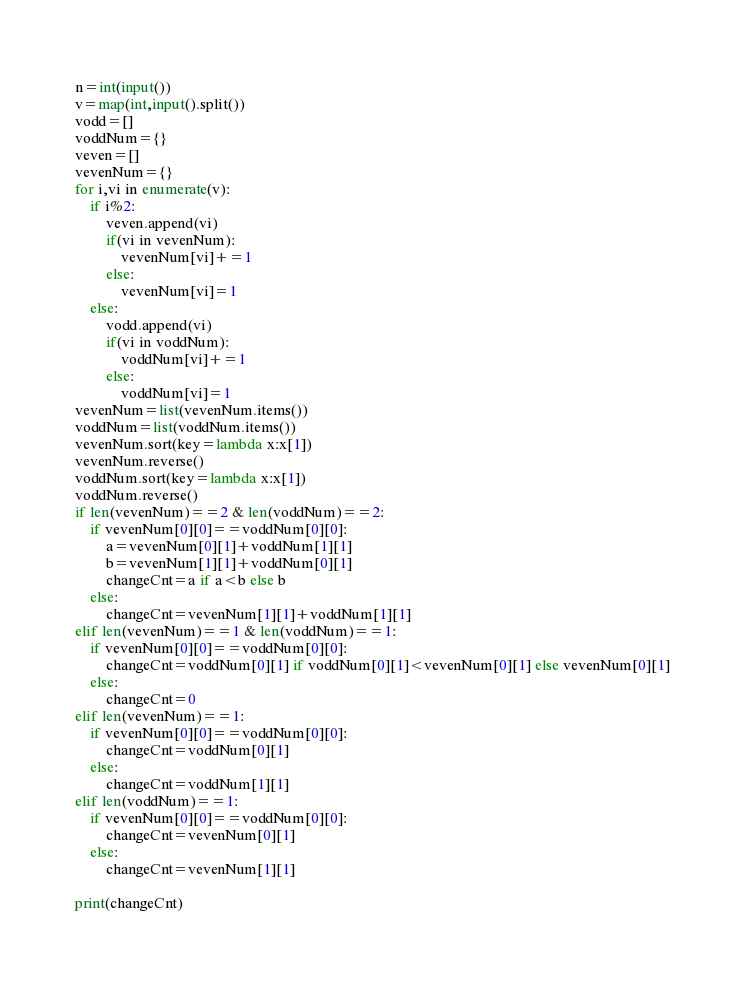Convert code to text. <code><loc_0><loc_0><loc_500><loc_500><_Python_>n=int(input())
v=map(int,input().split())
vodd=[]
voddNum={}
veven=[]
vevenNum={}
for i,vi in enumerate(v):
    if i%2:
        veven.append(vi)
        if(vi in vevenNum):
            vevenNum[vi]+=1
        else:
            vevenNum[vi]=1
    else:
        vodd.append(vi)
        if(vi in voddNum):
            voddNum[vi]+=1
        else:
            voddNum[vi]=1
vevenNum=list(vevenNum.items())
voddNum=list(voddNum.items())
vevenNum.sort(key=lambda x:x[1])
vevenNum.reverse()
voddNum.sort(key=lambda x:x[1])
voddNum.reverse()
if len(vevenNum)==2 & len(voddNum)==2:
    if vevenNum[0][0]==voddNum[0][0]:
        a=vevenNum[0][1]+voddNum[1][1]
        b=vevenNum[1][1]+voddNum[0][1]
        changeCnt=a if a<b else b
    else:
        changeCnt=vevenNum[1][1]+voddNum[1][1]
elif len(vevenNum)==1 & len(voddNum)==1:
    if vevenNum[0][0]==voddNum[0][0]:
        changeCnt=voddNum[0][1] if voddNum[0][1]<vevenNum[0][1] else vevenNum[0][1]
    else:
        changeCnt=0
elif len(vevenNum)==1:
    if vevenNum[0][0]==voddNum[0][0]:
        changeCnt=voddNum[0][1]
    else:
        changeCnt=voddNum[1][1]
elif len(voddNum)==1:
    if vevenNum[0][0]==voddNum[0][0]:
        changeCnt=vevenNum[0][1]
    else:
        changeCnt=vevenNum[1][1]

print(changeCnt)</code> 